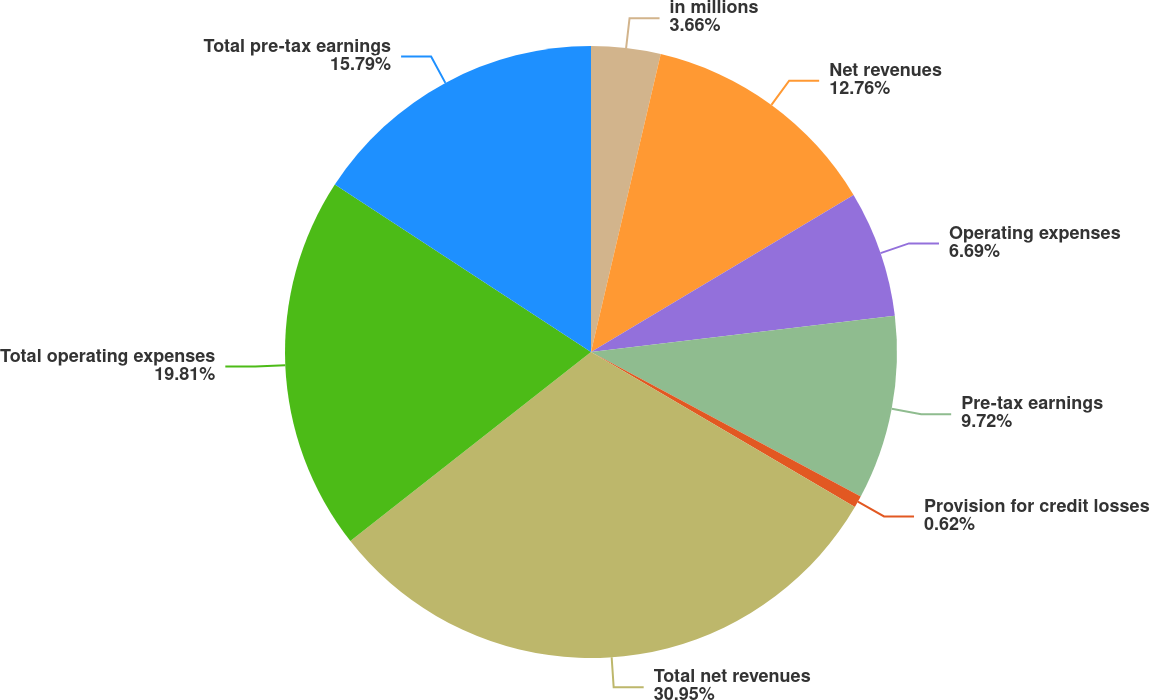<chart> <loc_0><loc_0><loc_500><loc_500><pie_chart><fcel>in millions<fcel>Net revenues<fcel>Operating expenses<fcel>Pre-tax earnings<fcel>Provision for credit losses<fcel>Total net revenues<fcel>Total operating expenses<fcel>Total pre-tax earnings<nl><fcel>3.66%<fcel>12.76%<fcel>6.69%<fcel>9.72%<fcel>0.62%<fcel>30.96%<fcel>19.81%<fcel>15.79%<nl></chart> 